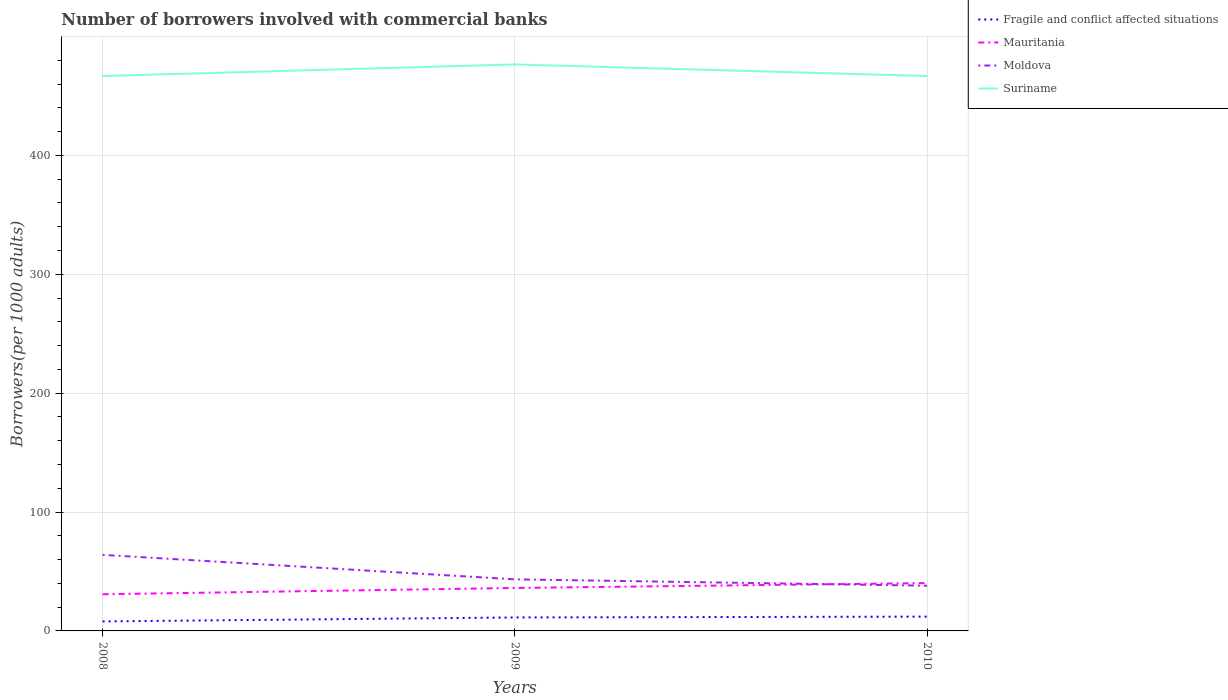How many different coloured lines are there?
Offer a terse response. 4. Does the line corresponding to Fragile and conflict affected situations intersect with the line corresponding to Mauritania?
Provide a short and direct response. No. Across all years, what is the maximum number of borrowers involved with commercial banks in Mauritania?
Ensure brevity in your answer.  30.85. What is the total number of borrowers involved with commercial banks in Mauritania in the graph?
Make the answer very short. -4.1. What is the difference between the highest and the second highest number of borrowers involved with commercial banks in Suriname?
Your answer should be very brief. 9.76. What is the difference between the highest and the lowest number of borrowers involved with commercial banks in Mauritania?
Ensure brevity in your answer.  2. Is the number of borrowers involved with commercial banks in Mauritania strictly greater than the number of borrowers involved with commercial banks in Fragile and conflict affected situations over the years?
Ensure brevity in your answer.  No. How many years are there in the graph?
Provide a short and direct response. 3. Are the values on the major ticks of Y-axis written in scientific E-notation?
Your response must be concise. No. Does the graph contain grids?
Your response must be concise. Yes. How are the legend labels stacked?
Keep it short and to the point. Vertical. What is the title of the graph?
Offer a terse response. Number of borrowers involved with commercial banks. Does "Tanzania" appear as one of the legend labels in the graph?
Your answer should be very brief. No. What is the label or title of the Y-axis?
Offer a terse response. Borrowers(per 1000 adults). What is the Borrowers(per 1000 adults) in Fragile and conflict affected situations in 2008?
Keep it short and to the point. 7.99. What is the Borrowers(per 1000 adults) in Mauritania in 2008?
Offer a terse response. 30.85. What is the Borrowers(per 1000 adults) in Moldova in 2008?
Offer a terse response. 63.99. What is the Borrowers(per 1000 adults) of Suriname in 2008?
Your answer should be very brief. 466.75. What is the Borrowers(per 1000 adults) in Fragile and conflict affected situations in 2009?
Your answer should be very brief. 11.33. What is the Borrowers(per 1000 adults) of Mauritania in 2009?
Keep it short and to the point. 36.13. What is the Borrowers(per 1000 adults) in Moldova in 2009?
Your answer should be compact. 43.38. What is the Borrowers(per 1000 adults) in Suriname in 2009?
Keep it short and to the point. 476.48. What is the Borrowers(per 1000 adults) in Fragile and conflict affected situations in 2010?
Provide a short and direct response. 12.03. What is the Borrowers(per 1000 adults) of Mauritania in 2010?
Keep it short and to the point. 40.23. What is the Borrowers(per 1000 adults) of Moldova in 2010?
Provide a succinct answer. 38.03. What is the Borrowers(per 1000 adults) of Suriname in 2010?
Keep it short and to the point. 466.73. Across all years, what is the maximum Borrowers(per 1000 adults) of Fragile and conflict affected situations?
Offer a terse response. 12.03. Across all years, what is the maximum Borrowers(per 1000 adults) in Mauritania?
Offer a terse response. 40.23. Across all years, what is the maximum Borrowers(per 1000 adults) of Moldova?
Provide a short and direct response. 63.99. Across all years, what is the maximum Borrowers(per 1000 adults) of Suriname?
Provide a short and direct response. 476.48. Across all years, what is the minimum Borrowers(per 1000 adults) of Fragile and conflict affected situations?
Offer a terse response. 7.99. Across all years, what is the minimum Borrowers(per 1000 adults) in Mauritania?
Your response must be concise. 30.85. Across all years, what is the minimum Borrowers(per 1000 adults) in Moldova?
Provide a succinct answer. 38.03. Across all years, what is the minimum Borrowers(per 1000 adults) in Suriname?
Make the answer very short. 466.73. What is the total Borrowers(per 1000 adults) of Fragile and conflict affected situations in the graph?
Offer a terse response. 31.35. What is the total Borrowers(per 1000 adults) in Mauritania in the graph?
Offer a very short reply. 107.21. What is the total Borrowers(per 1000 adults) in Moldova in the graph?
Provide a short and direct response. 145.4. What is the total Borrowers(per 1000 adults) of Suriname in the graph?
Ensure brevity in your answer.  1409.96. What is the difference between the Borrowers(per 1000 adults) in Fragile and conflict affected situations in 2008 and that in 2009?
Provide a succinct answer. -3.33. What is the difference between the Borrowers(per 1000 adults) in Mauritania in 2008 and that in 2009?
Offer a very short reply. -5.28. What is the difference between the Borrowers(per 1000 adults) of Moldova in 2008 and that in 2009?
Offer a very short reply. 20.61. What is the difference between the Borrowers(per 1000 adults) of Suriname in 2008 and that in 2009?
Give a very brief answer. -9.73. What is the difference between the Borrowers(per 1000 adults) in Fragile and conflict affected situations in 2008 and that in 2010?
Offer a very short reply. -4.04. What is the difference between the Borrowers(per 1000 adults) in Mauritania in 2008 and that in 2010?
Offer a very short reply. -9.38. What is the difference between the Borrowers(per 1000 adults) of Moldova in 2008 and that in 2010?
Make the answer very short. 25.95. What is the difference between the Borrowers(per 1000 adults) of Suriname in 2008 and that in 2010?
Make the answer very short. 0.03. What is the difference between the Borrowers(per 1000 adults) of Fragile and conflict affected situations in 2009 and that in 2010?
Offer a very short reply. -0.7. What is the difference between the Borrowers(per 1000 adults) in Mauritania in 2009 and that in 2010?
Keep it short and to the point. -4.1. What is the difference between the Borrowers(per 1000 adults) of Moldova in 2009 and that in 2010?
Your answer should be very brief. 5.34. What is the difference between the Borrowers(per 1000 adults) in Suriname in 2009 and that in 2010?
Give a very brief answer. 9.76. What is the difference between the Borrowers(per 1000 adults) in Fragile and conflict affected situations in 2008 and the Borrowers(per 1000 adults) in Mauritania in 2009?
Offer a very short reply. -28.14. What is the difference between the Borrowers(per 1000 adults) in Fragile and conflict affected situations in 2008 and the Borrowers(per 1000 adults) in Moldova in 2009?
Give a very brief answer. -35.38. What is the difference between the Borrowers(per 1000 adults) in Fragile and conflict affected situations in 2008 and the Borrowers(per 1000 adults) in Suriname in 2009?
Make the answer very short. -468.49. What is the difference between the Borrowers(per 1000 adults) of Mauritania in 2008 and the Borrowers(per 1000 adults) of Moldova in 2009?
Ensure brevity in your answer.  -12.53. What is the difference between the Borrowers(per 1000 adults) in Mauritania in 2008 and the Borrowers(per 1000 adults) in Suriname in 2009?
Offer a terse response. -445.64. What is the difference between the Borrowers(per 1000 adults) in Moldova in 2008 and the Borrowers(per 1000 adults) in Suriname in 2009?
Your answer should be compact. -412.5. What is the difference between the Borrowers(per 1000 adults) in Fragile and conflict affected situations in 2008 and the Borrowers(per 1000 adults) in Mauritania in 2010?
Provide a succinct answer. -32.24. What is the difference between the Borrowers(per 1000 adults) of Fragile and conflict affected situations in 2008 and the Borrowers(per 1000 adults) of Moldova in 2010?
Provide a succinct answer. -30.04. What is the difference between the Borrowers(per 1000 adults) in Fragile and conflict affected situations in 2008 and the Borrowers(per 1000 adults) in Suriname in 2010?
Make the answer very short. -458.73. What is the difference between the Borrowers(per 1000 adults) of Mauritania in 2008 and the Borrowers(per 1000 adults) of Moldova in 2010?
Keep it short and to the point. -7.19. What is the difference between the Borrowers(per 1000 adults) of Mauritania in 2008 and the Borrowers(per 1000 adults) of Suriname in 2010?
Make the answer very short. -435.88. What is the difference between the Borrowers(per 1000 adults) in Moldova in 2008 and the Borrowers(per 1000 adults) in Suriname in 2010?
Offer a terse response. -402.74. What is the difference between the Borrowers(per 1000 adults) in Fragile and conflict affected situations in 2009 and the Borrowers(per 1000 adults) in Mauritania in 2010?
Offer a very short reply. -28.9. What is the difference between the Borrowers(per 1000 adults) in Fragile and conflict affected situations in 2009 and the Borrowers(per 1000 adults) in Moldova in 2010?
Your response must be concise. -26.71. What is the difference between the Borrowers(per 1000 adults) in Fragile and conflict affected situations in 2009 and the Borrowers(per 1000 adults) in Suriname in 2010?
Make the answer very short. -455.4. What is the difference between the Borrowers(per 1000 adults) of Mauritania in 2009 and the Borrowers(per 1000 adults) of Moldova in 2010?
Offer a very short reply. -1.9. What is the difference between the Borrowers(per 1000 adults) in Mauritania in 2009 and the Borrowers(per 1000 adults) in Suriname in 2010?
Your answer should be compact. -430.59. What is the difference between the Borrowers(per 1000 adults) of Moldova in 2009 and the Borrowers(per 1000 adults) of Suriname in 2010?
Offer a very short reply. -423.35. What is the average Borrowers(per 1000 adults) of Fragile and conflict affected situations per year?
Your response must be concise. 10.45. What is the average Borrowers(per 1000 adults) of Mauritania per year?
Keep it short and to the point. 35.74. What is the average Borrowers(per 1000 adults) of Moldova per year?
Make the answer very short. 48.47. What is the average Borrowers(per 1000 adults) in Suriname per year?
Your answer should be very brief. 469.99. In the year 2008, what is the difference between the Borrowers(per 1000 adults) in Fragile and conflict affected situations and Borrowers(per 1000 adults) in Mauritania?
Provide a short and direct response. -22.85. In the year 2008, what is the difference between the Borrowers(per 1000 adults) of Fragile and conflict affected situations and Borrowers(per 1000 adults) of Moldova?
Your answer should be very brief. -56. In the year 2008, what is the difference between the Borrowers(per 1000 adults) of Fragile and conflict affected situations and Borrowers(per 1000 adults) of Suriname?
Your answer should be very brief. -458.76. In the year 2008, what is the difference between the Borrowers(per 1000 adults) in Mauritania and Borrowers(per 1000 adults) in Moldova?
Your response must be concise. -33.14. In the year 2008, what is the difference between the Borrowers(per 1000 adults) in Mauritania and Borrowers(per 1000 adults) in Suriname?
Your answer should be compact. -435.91. In the year 2008, what is the difference between the Borrowers(per 1000 adults) in Moldova and Borrowers(per 1000 adults) in Suriname?
Keep it short and to the point. -402.77. In the year 2009, what is the difference between the Borrowers(per 1000 adults) in Fragile and conflict affected situations and Borrowers(per 1000 adults) in Mauritania?
Your response must be concise. -24.8. In the year 2009, what is the difference between the Borrowers(per 1000 adults) of Fragile and conflict affected situations and Borrowers(per 1000 adults) of Moldova?
Offer a very short reply. -32.05. In the year 2009, what is the difference between the Borrowers(per 1000 adults) of Fragile and conflict affected situations and Borrowers(per 1000 adults) of Suriname?
Your answer should be very brief. -465.16. In the year 2009, what is the difference between the Borrowers(per 1000 adults) in Mauritania and Borrowers(per 1000 adults) in Moldova?
Ensure brevity in your answer.  -7.25. In the year 2009, what is the difference between the Borrowers(per 1000 adults) of Mauritania and Borrowers(per 1000 adults) of Suriname?
Offer a terse response. -440.35. In the year 2009, what is the difference between the Borrowers(per 1000 adults) of Moldova and Borrowers(per 1000 adults) of Suriname?
Make the answer very short. -433.11. In the year 2010, what is the difference between the Borrowers(per 1000 adults) of Fragile and conflict affected situations and Borrowers(per 1000 adults) of Mauritania?
Your response must be concise. -28.2. In the year 2010, what is the difference between the Borrowers(per 1000 adults) of Fragile and conflict affected situations and Borrowers(per 1000 adults) of Moldova?
Offer a terse response. -26. In the year 2010, what is the difference between the Borrowers(per 1000 adults) of Fragile and conflict affected situations and Borrowers(per 1000 adults) of Suriname?
Provide a succinct answer. -454.69. In the year 2010, what is the difference between the Borrowers(per 1000 adults) in Mauritania and Borrowers(per 1000 adults) in Moldova?
Offer a very short reply. 2.2. In the year 2010, what is the difference between the Borrowers(per 1000 adults) in Mauritania and Borrowers(per 1000 adults) in Suriname?
Give a very brief answer. -426.5. In the year 2010, what is the difference between the Borrowers(per 1000 adults) of Moldova and Borrowers(per 1000 adults) of Suriname?
Provide a short and direct response. -428.69. What is the ratio of the Borrowers(per 1000 adults) of Fragile and conflict affected situations in 2008 to that in 2009?
Offer a terse response. 0.71. What is the ratio of the Borrowers(per 1000 adults) of Mauritania in 2008 to that in 2009?
Your answer should be very brief. 0.85. What is the ratio of the Borrowers(per 1000 adults) in Moldova in 2008 to that in 2009?
Make the answer very short. 1.48. What is the ratio of the Borrowers(per 1000 adults) in Suriname in 2008 to that in 2009?
Ensure brevity in your answer.  0.98. What is the ratio of the Borrowers(per 1000 adults) in Fragile and conflict affected situations in 2008 to that in 2010?
Offer a very short reply. 0.66. What is the ratio of the Borrowers(per 1000 adults) of Mauritania in 2008 to that in 2010?
Keep it short and to the point. 0.77. What is the ratio of the Borrowers(per 1000 adults) of Moldova in 2008 to that in 2010?
Offer a very short reply. 1.68. What is the ratio of the Borrowers(per 1000 adults) in Suriname in 2008 to that in 2010?
Your answer should be very brief. 1. What is the ratio of the Borrowers(per 1000 adults) in Fragile and conflict affected situations in 2009 to that in 2010?
Keep it short and to the point. 0.94. What is the ratio of the Borrowers(per 1000 adults) in Mauritania in 2009 to that in 2010?
Keep it short and to the point. 0.9. What is the ratio of the Borrowers(per 1000 adults) in Moldova in 2009 to that in 2010?
Your response must be concise. 1.14. What is the ratio of the Borrowers(per 1000 adults) in Suriname in 2009 to that in 2010?
Your response must be concise. 1.02. What is the difference between the highest and the second highest Borrowers(per 1000 adults) of Fragile and conflict affected situations?
Your answer should be very brief. 0.7. What is the difference between the highest and the second highest Borrowers(per 1000 adults) of Mauritania?
Keep it short and to the point. 4.1. What is the difference between the highest and the second highest Borrowers(per 1000 adults) in Moldova?
Your response must be concise. 20.61. What is the difference between the highest and the second highest Borrowers(per 1000 adults) in Suriname?
Ensure brevity in your answer.  9.73. What is the difference between the highest and the lowest Borrowers(per 1000 adults) of Fragile and conflict affected situations?
Offer a terse response. 4.04. What is the difference between the highest and the lowest Borrowers(per 1000 adults) in Mauritania?
Provide a short and direct response. 9.38. What is the difference between the highest and the lowest Borrowers(per 1000 adults) in Moldova?
Your response must be concise. 25.95. What is the difference between the highest and the lowest Borrowers(per 1000 adults) in Suriname?
Offer a terse response. 9.76. 